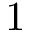<formula> <loc_0><loc_0><loc_500><loc_500>1</formula> 